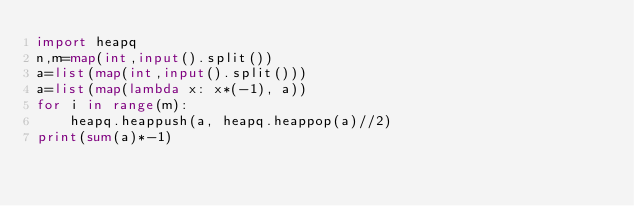Convert code to text. <code><loc_0><loc_0><loc_500><loc_500><_Python_>import heapq
n,m=map(int,input().split())
a=list(map(int,input().split()))
a=list(map(lambda x: x*(-1), a))
for i in range(m):
    heapq.heappush(a, heapq.heappop(a)//2)
print(sum(a)*-1)
</code> 